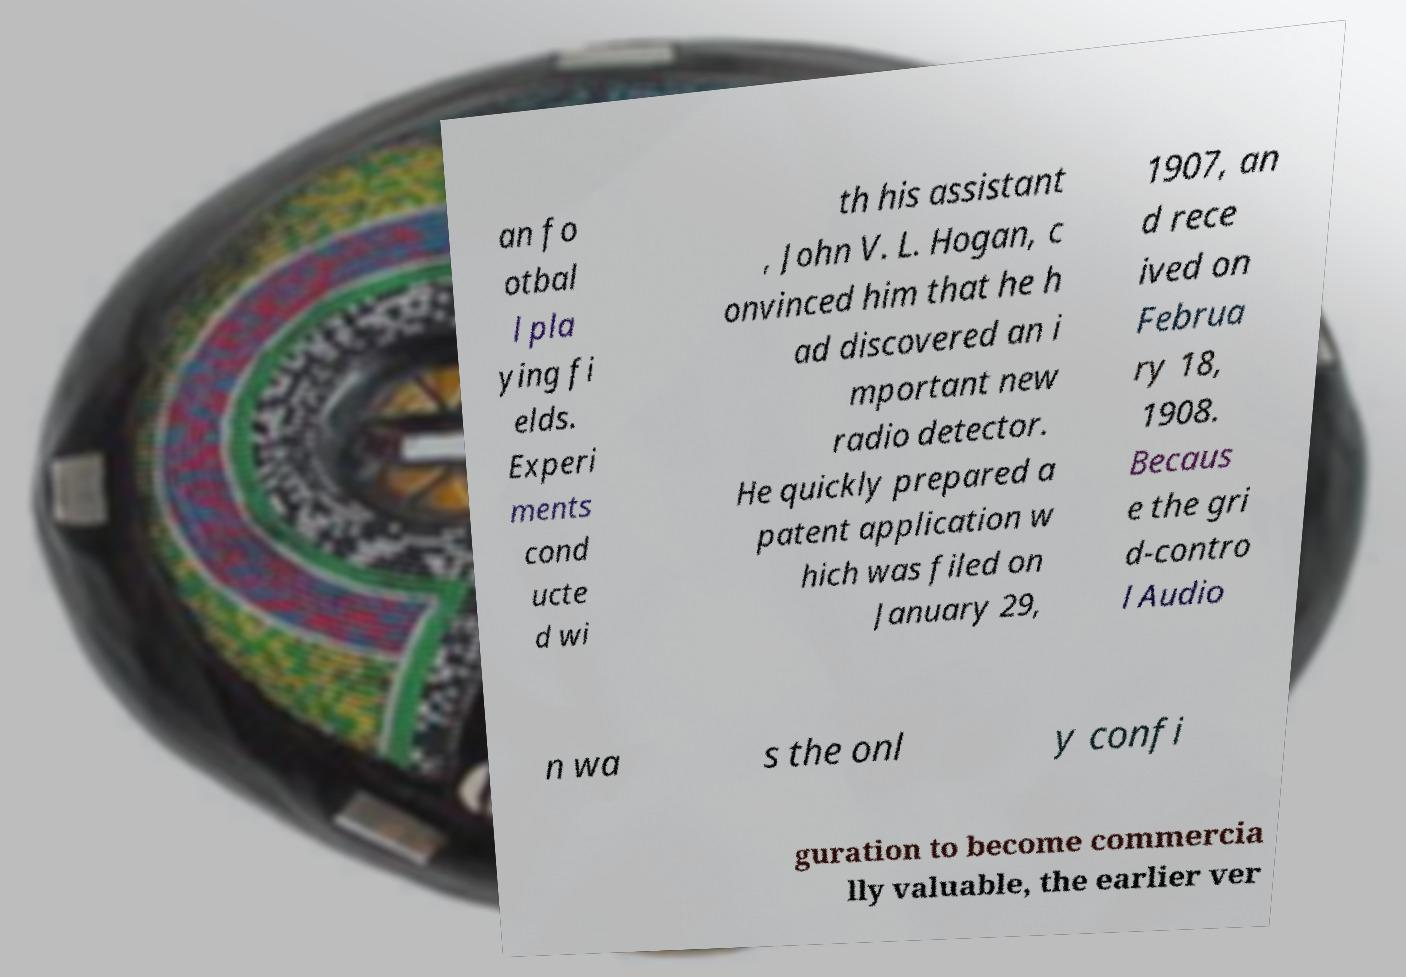Please read and relay the text visible in this image. What does it say? an fo otbal l pla ying fi elds. Experi ments cond ucte d wi th his assistant , John V. L. Hogan, c onvinced him that he h ad discovered an i mportant new radio detector. He quickly prepared a patent application w hich was filed on January 29, 1907, an d rece ived on Februa ry 18, 1908. Becaus e the gri d-contro l Audio n wa s the onl y confi guration to become commercia lly valuable, the earlier ver 